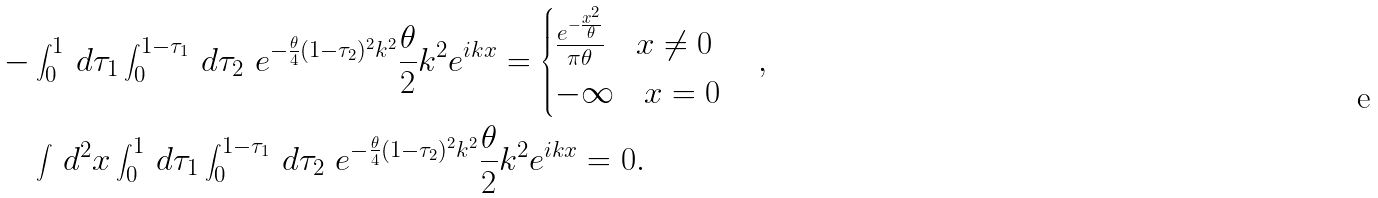Convert formula to latex. <formula><loc_0><loc_0><loc_500><loc_500>- & \int _ { 0 } ^ { 1 } \, d \tau _ { 1 } \int _ { 0 } ^ { 1 - \tau _ { 1 } } \, d \tau _ { 2 } \ e ^ { - \frac { \theta } { 4 } ( 1 - \tau _ { 2 } ) ^ { 2 } k ^ { 2 } } \frac { \theta } { 2 } k ^ { 2 } e ^ { i k x } = \begin{cases} \frac { e ^ { - \frac { x ^ { 2 } } { \theta } } } { \pi \theta } \quad x \ne 0 \\ - \infty \quad x = 0 \end{cases} , \\ & \int \, d ^ { 2 } x \int _ { 0 } ^ { 1 } \, d \tau _ { 1 } \int _ { 0 } ^ { 1 - \tau _ { 1 } } \, d \tau _ { 2 } \ e ^ { - \frac { \theta } { 4 } ( 1 - \tau _ { 2 } ) ^ { 2 } k ^ { 2 } } \frac { \theta } { 2 } k ^ { 2 } e ^ { i k x } = 0 .</formula> 